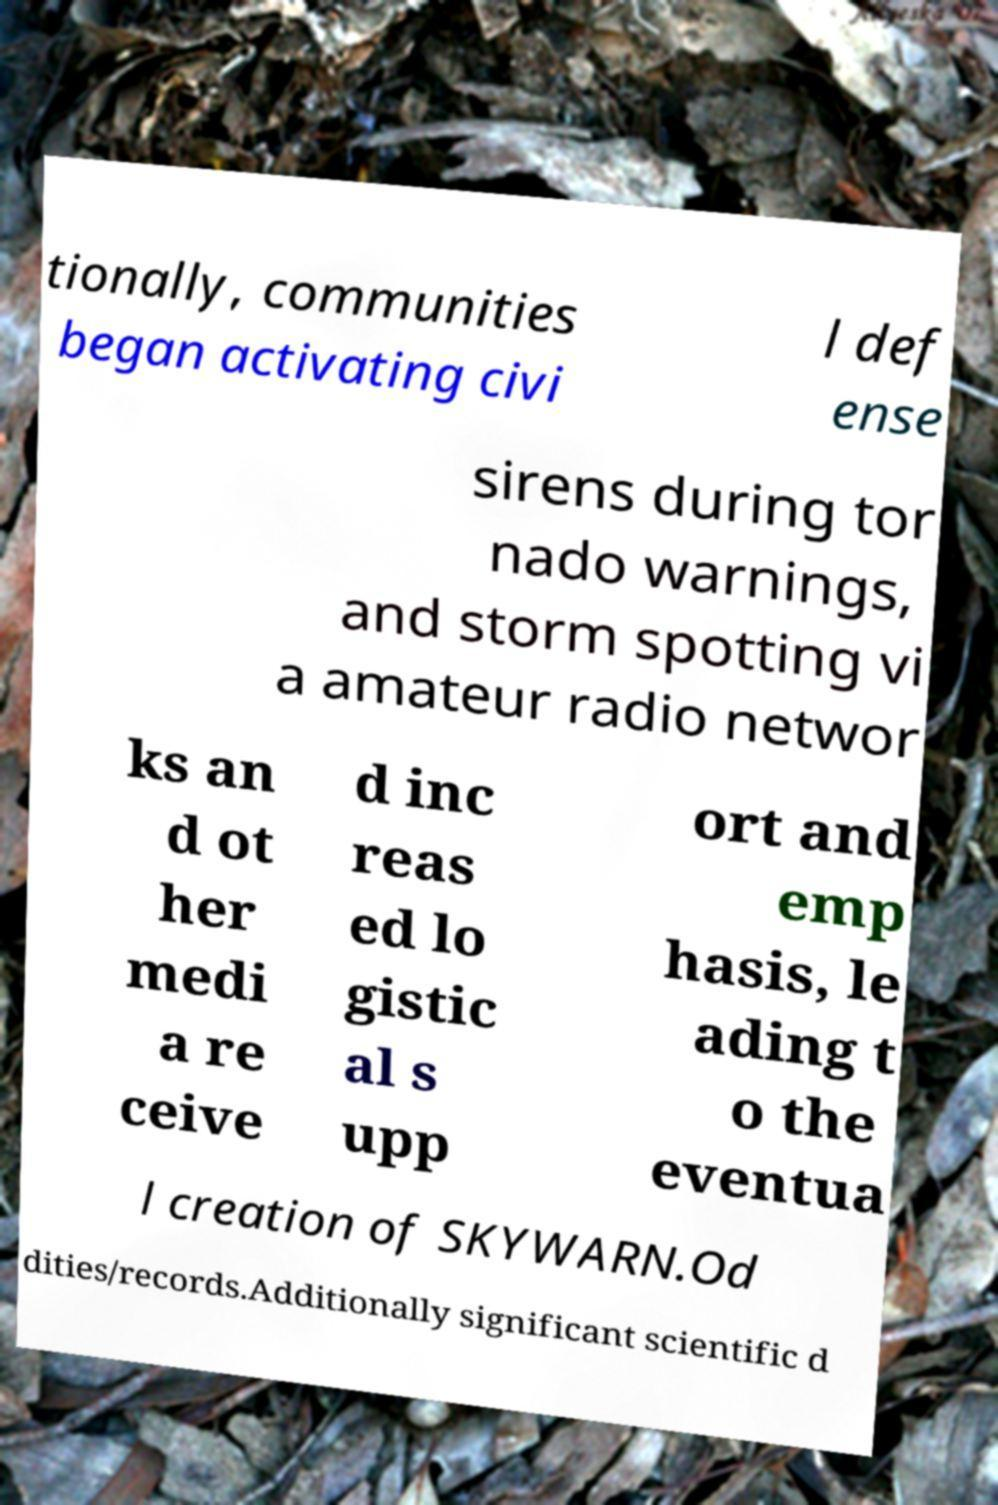I need the written content from this picture converted into text. Can you do that? tionally, communities began activating civi l def ense sirens during tor nado warnings, and storm spotting vi a amateur radio networ ks an d ot her medi a re ceive d inc reas ed lo gistic al s upp ort and emp hasis, le ading t o the eventua l creation of SKYWARN.Od dities/records.Additionally significant scientific d 